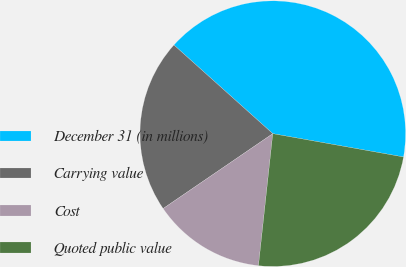<chart> <loc_0><loc_0><loc_500><loc_500><pie_chart><fcel>December 31 (in millions)<fcel>Carrying value<fcel>Cost<fcel>Quoted public value<nl><fcel>41.17%<fcel>21.17%<fcel>13.74%<fcel>23.91%<nl></chart> 